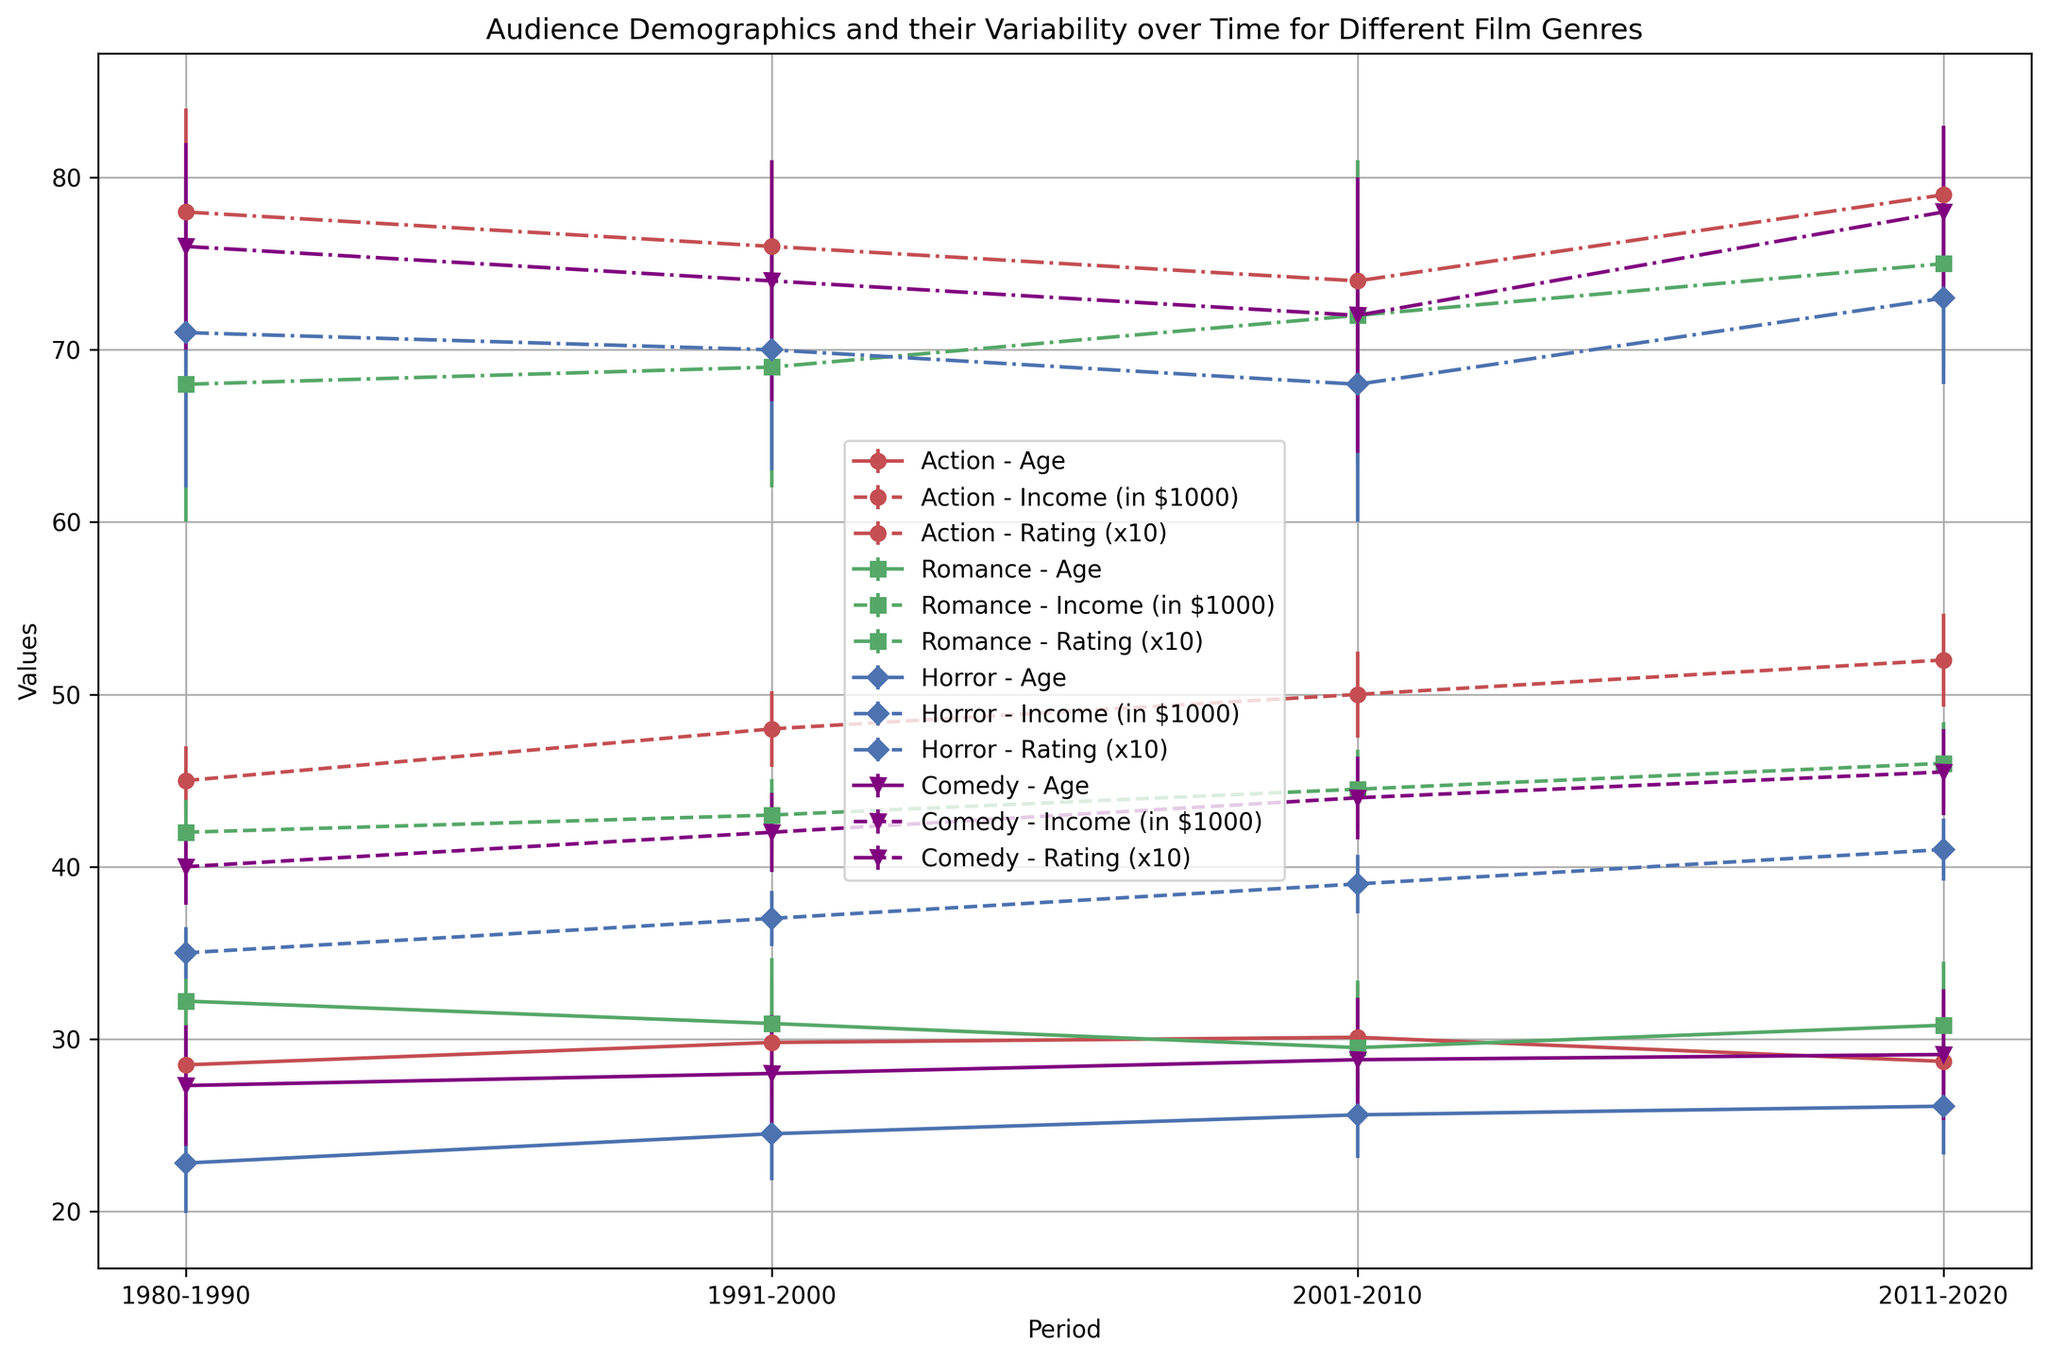Which genre has the highest mean age in the period 1980-1990? In the plot, we look for the point corresponding to the age of audiences from 1980-1990 for each genre. The genre with the highest mean age will have the highest point on the age-related error bars.
Answer: Romance How has the mean rating of Action films changed from 2001-2010 to 2011-2020? Locate the points corresponding to Action films in both 2001-2010 and 2011-2020 periods in the plot. Compare their vertical positions.
Answer: Increased by 0.5 Which genre shows the largest variability in audience income in the period 2011-2020? We find the error bars representing the standard deviation of audience income for different genres in the period 2011-2020. The genre with the largest error bar has the most variability.
Answer: Action What is the pattern of mean age trends for Horror films over the four periods? Observe the points and their connections for the mean age of Horror films across 1980-1990, 1991-2000, 2001-2010, 2011-2020 periods. Note the trend (whether it increases or decreases).
Answer: Increasing trend Compare the average income of Comedy film audiences to Romance film audiences in the period 2001-2010. Locate and compare the points corresponding to the mean income of audiences for Comedy and Romance films in the 2001-2010 period.
Answer: Comedy > Romance Which genre has shown the most significant increase in mean rating from 1991-2000 to 2011-2020? Analyze the changes in mean ratings for each genre from 1991-2000 to 2011-2020. Note the differences and identify the maximum increase.
Answer: Romance What is the approximate interval for ages of Action film audiences in the period 1980-1990 when considering variability? Check the error bar representing the mean age and standard deviation for Action films in the 1980-1990 period. Calculate the interval using mean ± standard deviation.
Answer: 25.3 - 31.7 years Compare the trends of average income for Action and Horror films from 1980-2020. Observe the error bars for the mean income of Action and Horror films over the periods 1980-1990, 1991-2000, 2001-2010, and 2011-2020.
Answer: Both increasing Which period had the lowest standard deviation in mean age for Comedy films? Look for the error bars representing the standard deviation of mean age for Comedy films within each period and identify the shortest error bar.
Answer: 2001-2010 In which period did Romance films see the highest audience rating? Identify the points corresponding to the mean rating for Romance films in each period and note the highest point.
Answer: 2011-2020 